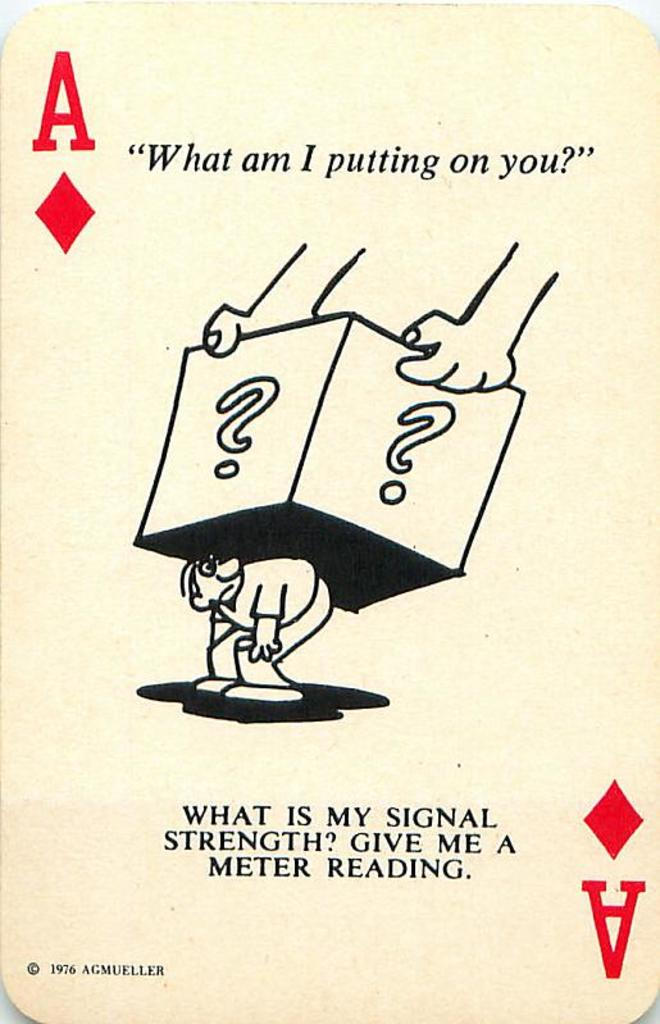What do you see happening in this image? The image depicts a whimsical and thought-provoking playing card, the Ace of Diamonds, dating back to 1976. This card, manufactured by AGMÜLLER, features a cartoon character weighed down by two large question mark boxes, which are suspended from unseen hands above. The character appears troubled or confused, adding a layer of intrigue or metaphor about carrying the weight of unknowns or indecisions. This evocative design is most likely used to engage the viewer in considering their own 'burdens' or 'uncertainties' in life. The text prompts, 'What am I putting on you?' and 'What is my signal strength? Give me a meter reading.', perhaps subtly question the viewer's perception of external pressures and communication quality, respectively, making this card not only a collectible but also a piece of philosophical art. 